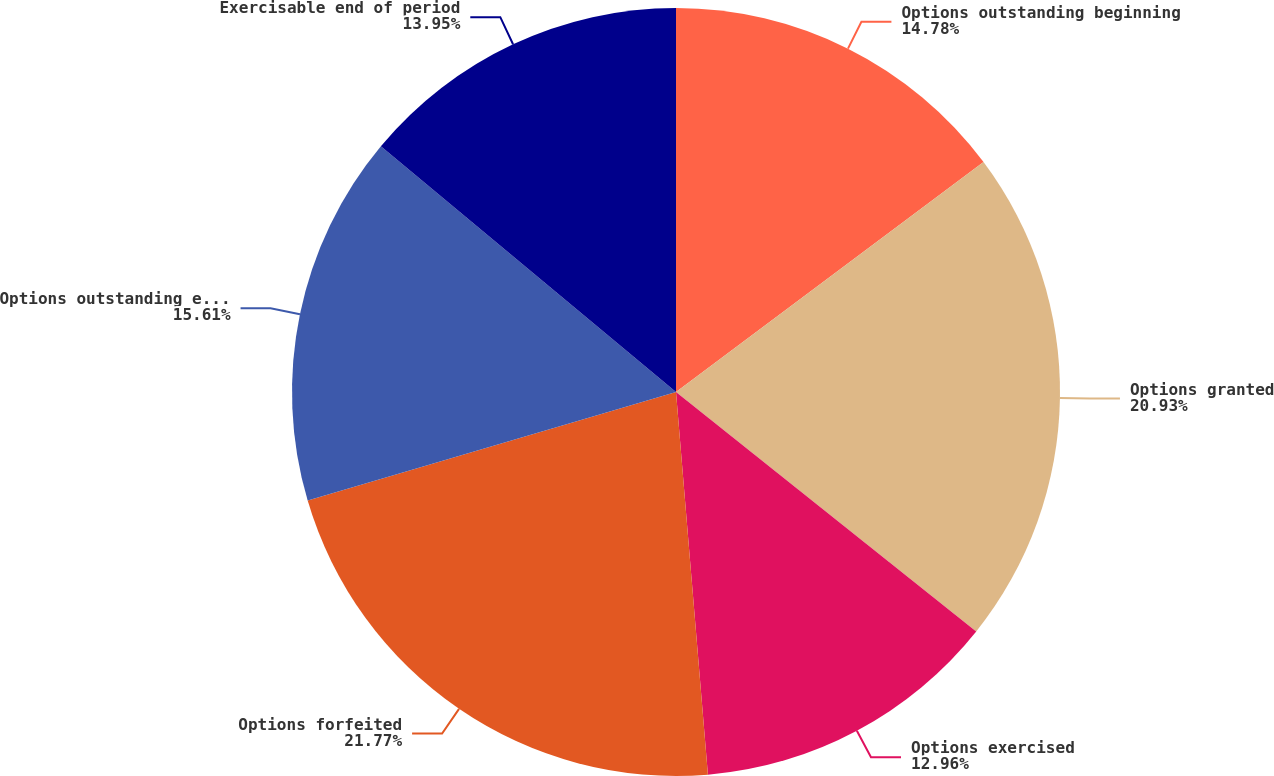<chart> <loc_0><loc_0><loc_500><loc_500><pie_chart><fcel>Options outstanding beginning<fcel>Options granted<fcel>Options exercised<fcel>Options forfeited<fcel>Options outstanding end of<fcel>Exercisable end of period<nl><fcel>14.78%<fcel>20.93%<fcel>12.96%<fcel>21.76%<fcel>15.61%<fcel>13.95%<nl></chart> 